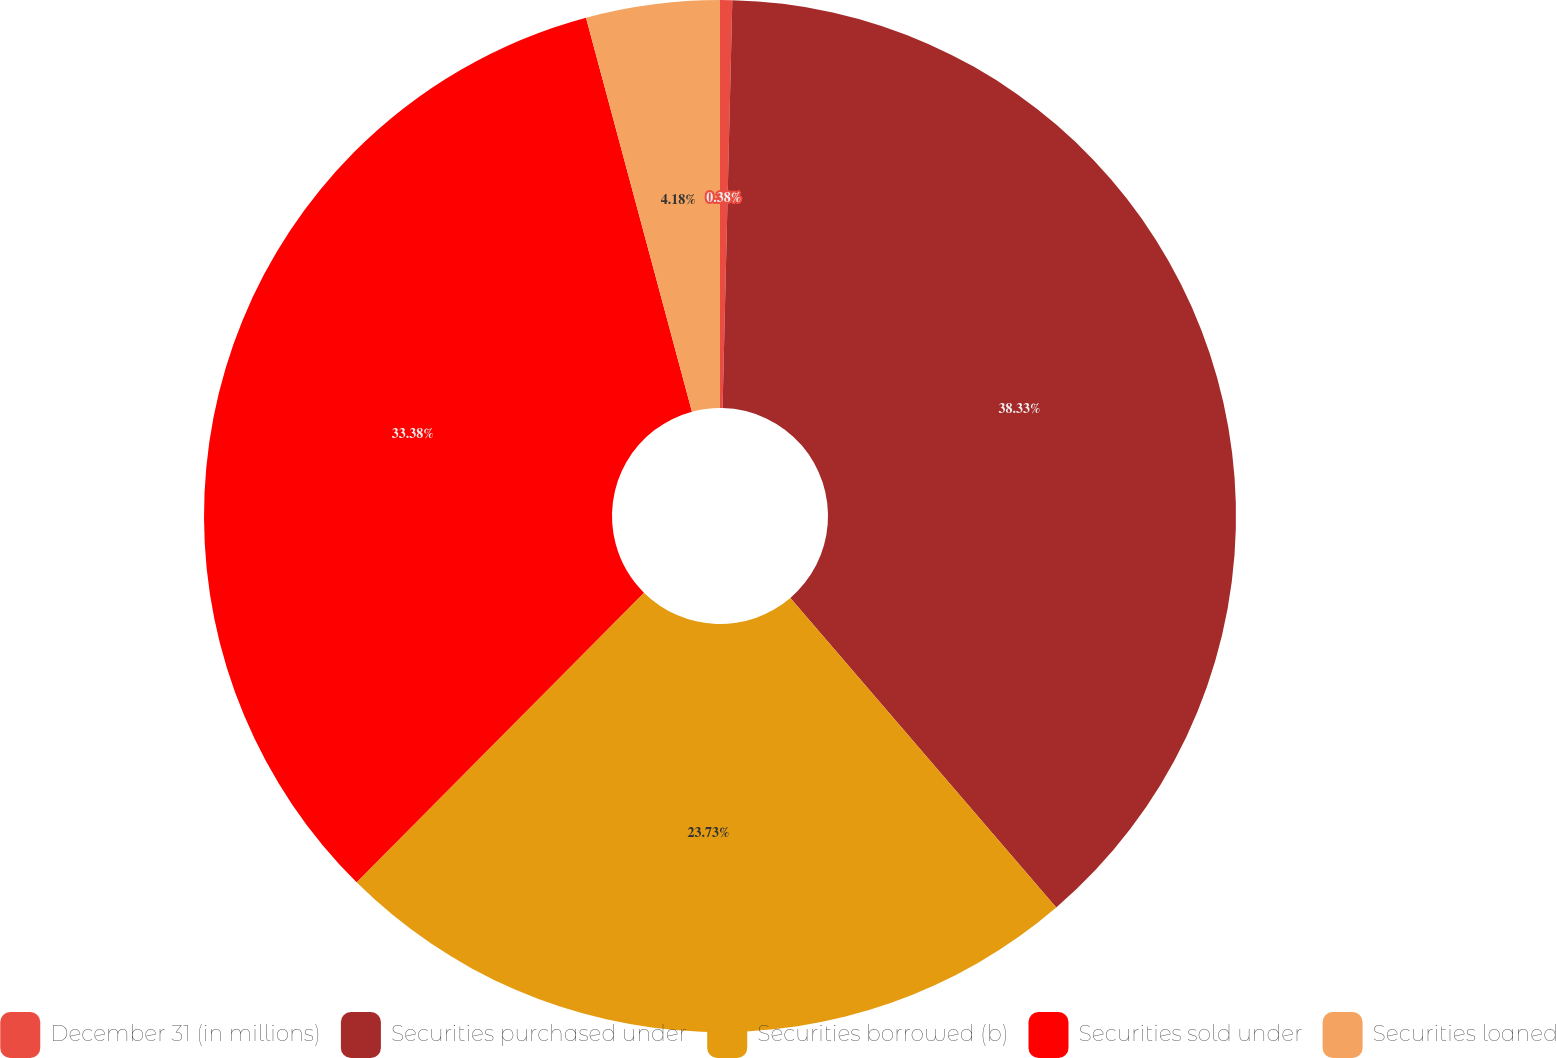Convert chart to OTSL. <chart><loc_0><loc_0><loc_500><loc_500><pie_chart><fcel>December 31 (in millions)<fcel>Securities purchased under<fcel>Securities borrowed (b)<fcel>Securities sold under<fcel>Securities loaned<nl><fcel>0.38%<fcel>38.32%<fcel>23.73%<fcel>33.38%<fcel>4.18%<nl></chart> 